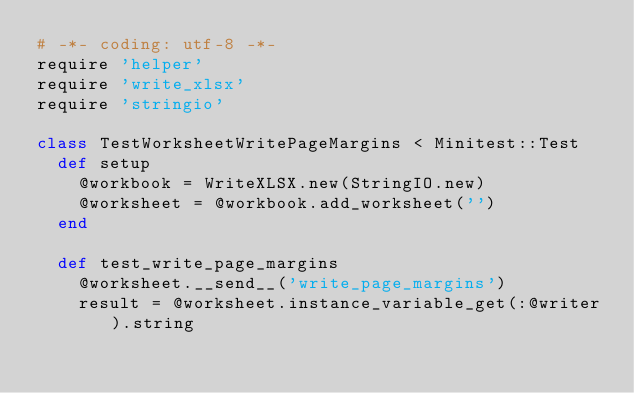<code> <loc_0><loc_0><loc_500><loc_500><_Ruby_># -*- coding: utf-8 -*-
require 'helper'
require 'write_xlsx'
require 'stringio'

class TestWorksheetWritePageMargins < Minitest::Test
  def setup
    @workbook = WriteXLSX.new(StringIO.new)
    @worksheet = @workbook.add_worksheet('')
  end

  def test_write_page_margins
    @worksheet.__send__('write_page_margins')
    result = @worksheet.instance_variable_get(:@writer).string</code> 